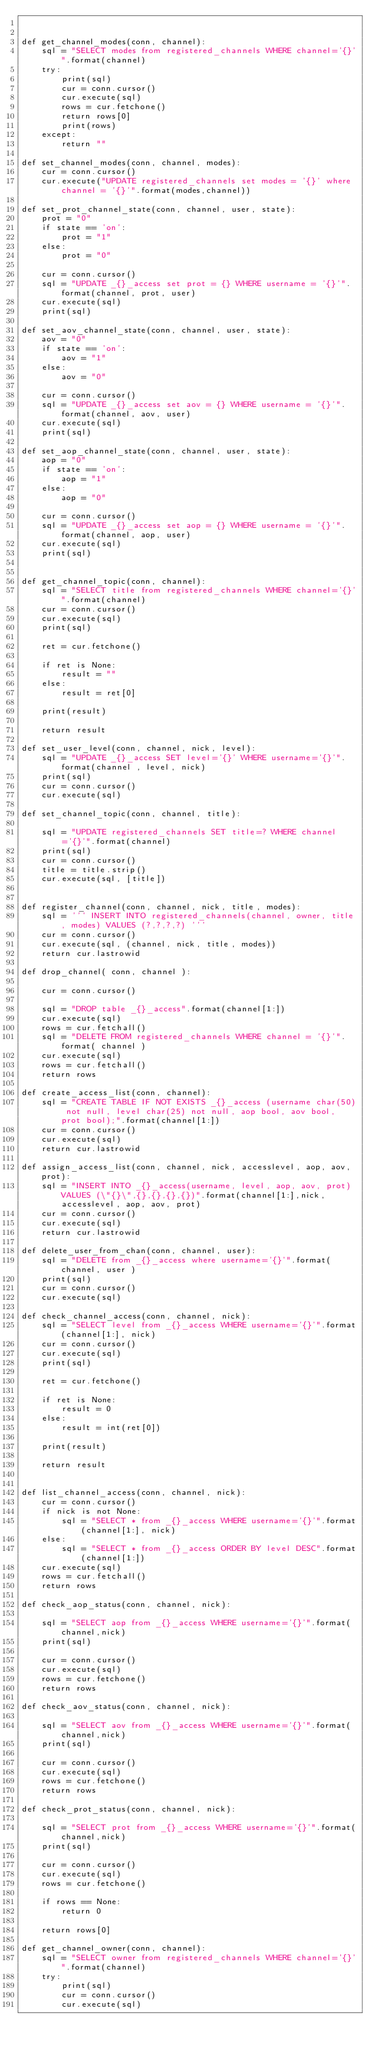Convert code to text. <code><loc_0><loc_0><loc_500><loc_500><_Python_>

def get_channel_modes(conn, channel):
    sql = "SELECT modes from registered_channels WHERE channel='{}'".format(channel)
    try:
        print(sql)
        cur = conn.cursor()
        cur.execute(sql)
        rows = cur.fetchone()
        return rows[0]
        print(rows)
    except:
        return ""
 
def set_channel_modes(conn, channel, modes):
    cur = conn.cursor()
    cur.execute("UPDATE registered_channels set modes = '{}' where channel = '{}'".format(modes,channel))    
   
def set_prot_channel_state(conn, channel, user, state):
    prot = "0"
    if state == 'on':
        prot = "1"
    else:
        prot = "0"
    
    cur = conn.cursor()
    sql = "UPDATE _{}_access set prot = {} WHERE username = '{}'".format(channel, prot, user)
    cur.execute(sql)
    print(sql)

def set_aov_channel_state(conn, channel, user, state):
    aov = "0"
    if state == 'on':
        aov = "1"
    else:
        aov = "0"
    
    cur = conn.cursor()
    sql = "UPDATE _{}_access set aov = {} WHERE username = '{}'".format(channel, aov, user)
    cur.execute(sql)
    print(sql)

def set_aop_channel_state(conn, channel, user, state):
    aop = "0"
    if state == 'on':
        aop = "1"
    else:
        aop = "0"
    
    cur = conn.cursor()
    sql = "UPDATE _{}_access set aop = {} WHERE username = '{}'".format(channel, aop, user)
    cur.execute(sql)
    print(sql)

   
def get_channel_topic(conn, channel):
    sql = "SELECT title from registered_channels WHERE channel='{}'".format(channel)
    cur = conn.cursor()
    cur.execute(sql)
    print(sql)
 
    ret = cur.fetchone()
    
    if ret is None:
        result = ""
    else:
        result = ret[0]
        
    print(result)
   
    return result    

def set_user_level(conn, channel, nick, level):
    sql = "UPDATE _{}_access SET level='{}' WHERE username='{}'".format(channel , level, nick)
    print(sql)
    cur = conn.cursor()
    cur.execute(sql)    
 
def set_channel_topic(conn, channel, title):

    sql = "UPDATE registered_channels SET title=? WHERE channel='{}'".format(channel)
    print(sql)
    cur = conn.cursor()
    title = title.strip()
    cur.execute(sql, [title])


def register_channel(conn, channel, nick, title, modes):
    sql = ''' INSERT INTO registered_channels(channel, owner, title, modes) VALUES (?,?,?,?) '''
    cur = conn.cursor()
    cur.execute(sql, (channel, nick, title, modes))
    return cur.lastrowid
    
def drop_channel( conn, channel ):
 
    cur = conn.cursor()
 
    sql = "DROP table _{}_access".format(channel[1:])
    cur.execute(sql)
    rows = cur.fetchall()
    sql = "DELETE FROM registered_channels WHERE channel = '{}'".format( channel )
    cur.execute(sql)
    rows = cur.fetchall()
    return rows

def create_access_list(conn, channel):
    sql = "CREATE TABLE IF NOT EXISTS _{}_access (username char(50) not null, level char(25) not null, aop bool, aov bool, prot bool);".format(channel[1:])
    cur = conn.cursor()
    cur.execute(sql)
    return cur.lastrowid

def assign_access_list(conn, channel, nick, accesslevel, aop, aov, prot):
    sql = "INSERT INTO _{}_access(username, level, aop, aov, prot) VALUES (\"{}\",{},{},{},{})".format(channel[1:],nick,accesslevel, aop, aov, prot)
    cur = conn.cursor()
    cur.execute(sql)
    return cur.lastrowid

def delete_user_from_chan(conn, channel, user):
    sql = "DELETE from _{}_access where username='{}'".format( channel, user )
    print(sql)
    cur = conn.cursor()
    cur.execute(sql)

def check_channel_access(conn, channel, nick):
    sql = "SELECT level from _{}_access WHERE username='{}'".format(channel[1:], nick)
    cur = conn.cursor()
    cur.execute(sql)
    print(sql)
 
    ret = cur.fetchone()
    
    if ret is None:
        result = 0
    else:
        result = int(ret[0])
        
    print(result)
   
    return result


def list_channel_access(conn, channel, nick):
    cur = conn.cursor()
    if nick is not None:
        sql = "SELECT * from _{}_access WHERE username='{}'".format(channel[1:], nick)
    else:
        sql = "SELECT * from _{}_access ORDER BY level DESC".format(channel[1:])
    cur.execute(sql)
    rows = cur.fetchall()
    return rows

def check_aop_status(conn, channel, nick):
  
    sql = "SELECT aop from _{}_access WHERE username='{}'".format(channel,nick)
    print(sql)
 
    cur = conn.cursor()
    cur.execute(sql)
    rows = cur.fetchone()
    return rows

def check_aov_status(conn, channel, nick):
  
    sql = "SELECT aov from _{}_access WHERE username='{}'".format(channel,nick)
    print(sql)
 
    cur = conn.cursor()
    cur.execute(sql)
    rows = cur.fetchone()
    return rows

def check_prot_status(conn, channel, nick):
  
    sql = "SELECT prot from _{}_access WHERE username='{}'".format(channel,nick)
    print(sql)
 
    cur = conn.cursor()
    cur.execute(sql)
    rows = cur.fetchone()
    
    if rows == None:
        return 0
  
    return rows[0]

def get_channel_owner(conn, channel):
    sql = "SELECT owner from registered_channels WHERE channel='{}'".format(channel)
    try:
        print(sql)
        cur = conn.cursor()
        cur.execute(sql)</code> 